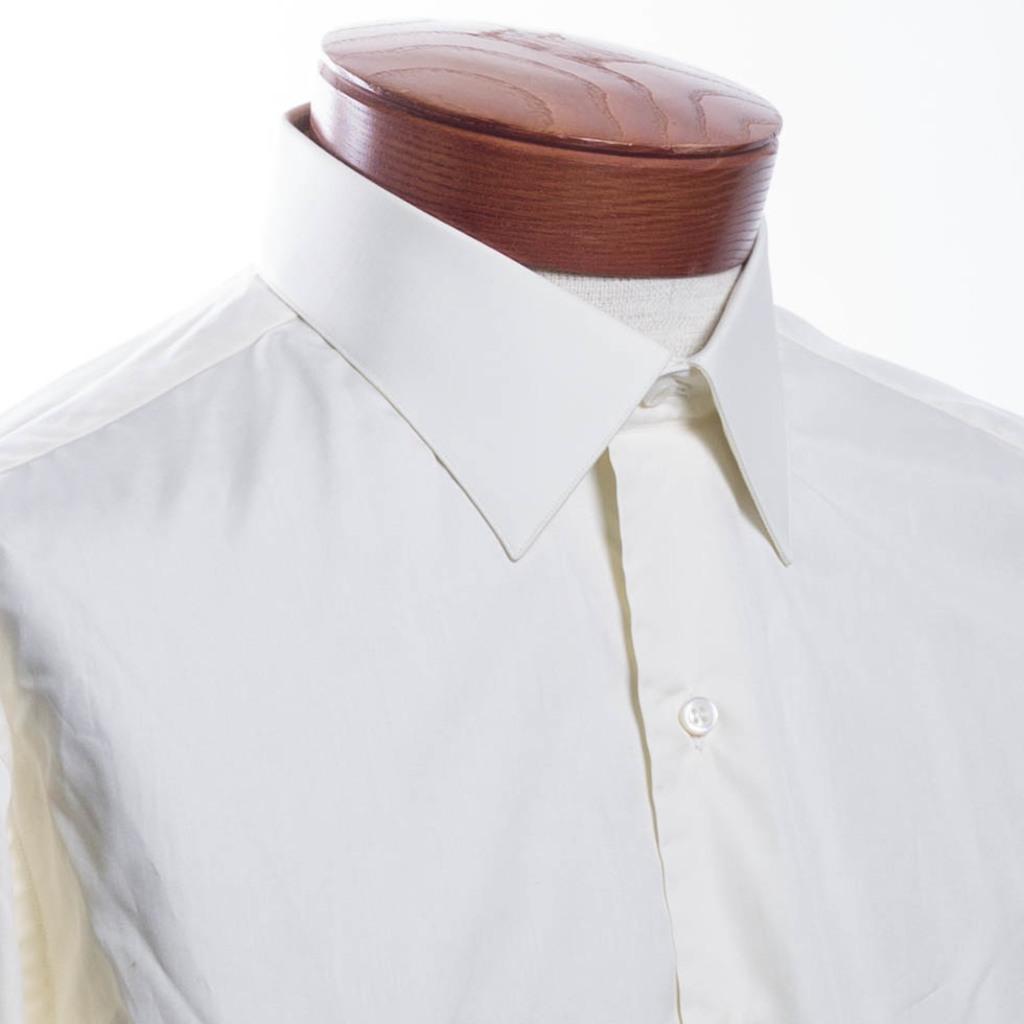In one or two sentences, can you explain what this image depicts? In this image, we can see there is a white color shirt to a mannequin. And the background is white in color. 